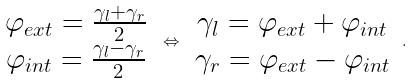Convert formula to latex. <formula><loc_0><loc_0><loc_500><loc_500>\begin{array} { c } \varphi _ { e x t } = \frac { \gamma _ { l } + \gamma _ { r } } { 2 } \\ \varphi _ { i n t } = \frac { \gamma _ { l } - \gamma _ { r } } { 2 } \end{array} \, \Leftrightarrow \, \begin{array} { c } \gamma _ { l } = \varphi _ { e x t } + \varphi _ { i n t } \\ \gamma _ { r } = \varphi _ { e x t } - \varphi _ { i n t } \end{array} \, .</formula> 